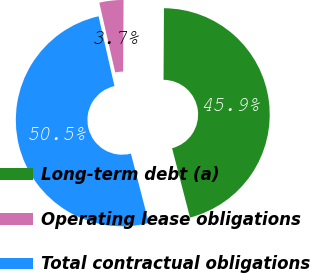<chart> <loc_0><loc_0><loc_500><loc_500><pie_chart><fcel>Long-term debt (a)<fcel>Operating lease obligations<fcel>Total contractual obligations<nl><fcel>45.87%<fcel>3.66%<fcel>50.46%<nl></chart> 